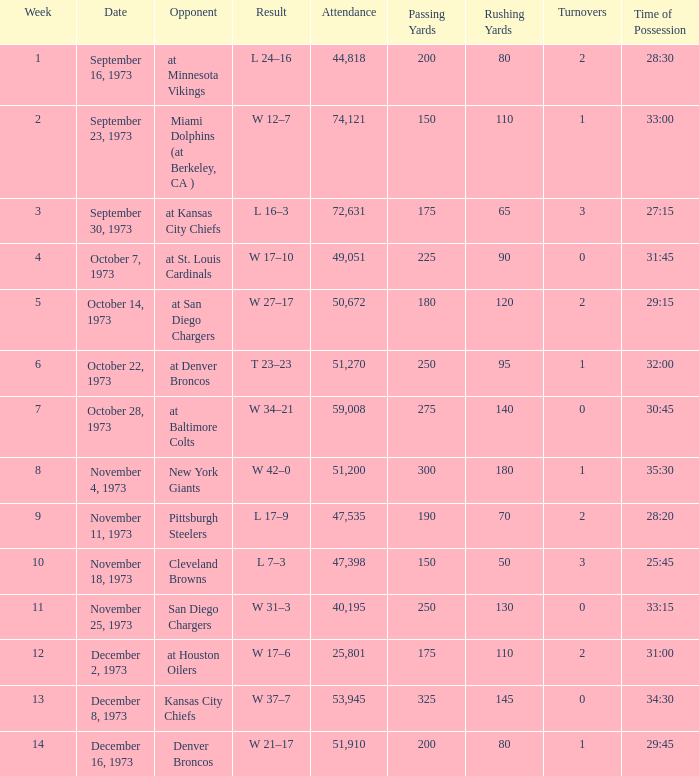What is the result later than week 13? W 21–17. 